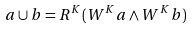<formula> <loc_0><loc_0><loc_500><loc_500>a \cup b = R ^ { K } ( W ^ { K } a \wedge W ^ { K } b )</formula> 